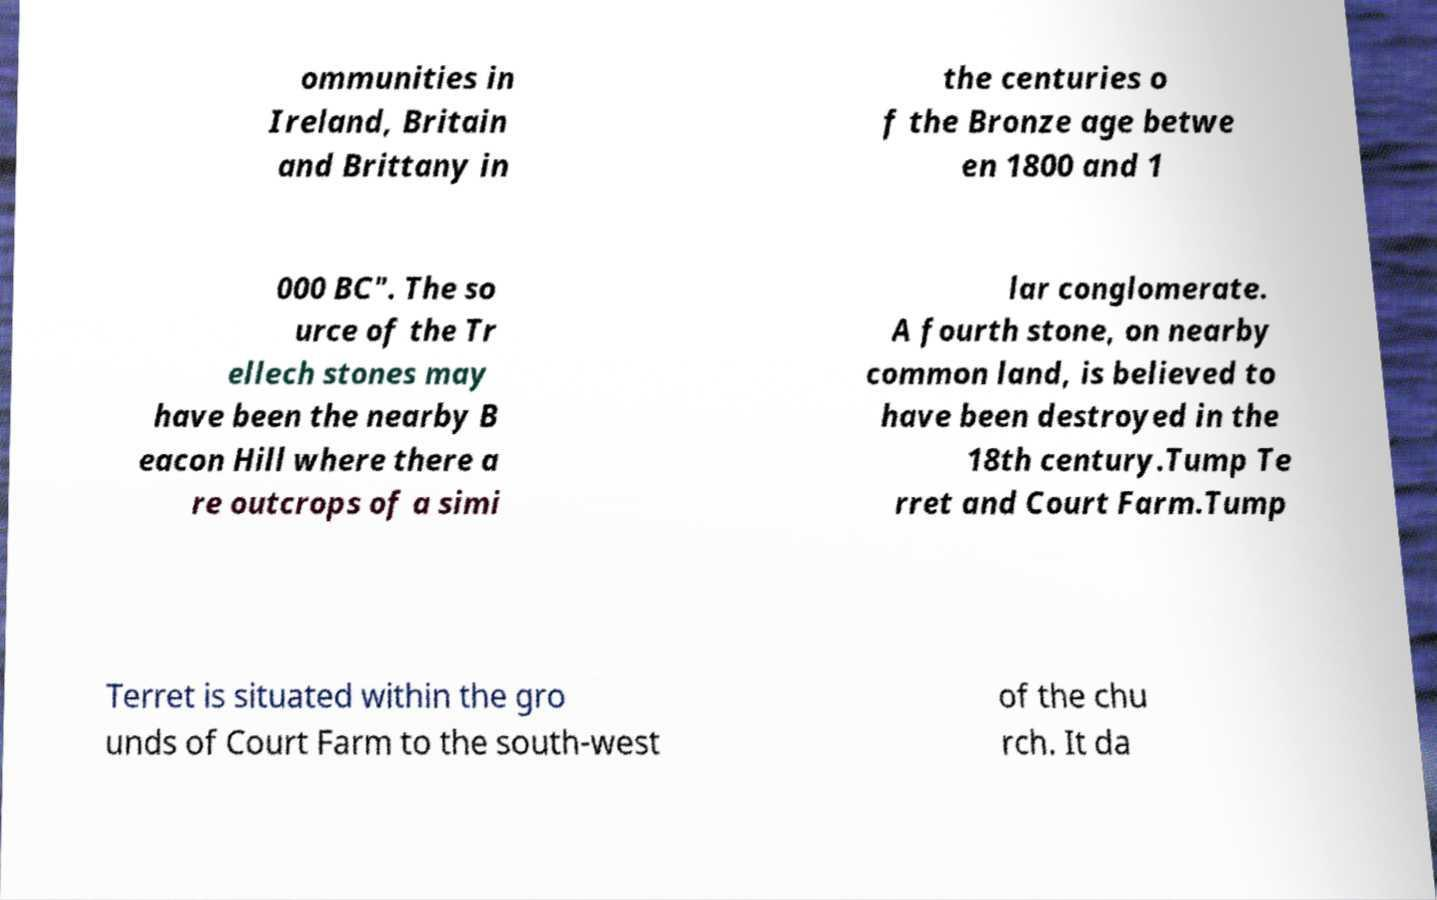I need the written content from this picture converted into text. Can you do that? ommunities in Ireland, Britain and Brittany in the centuries o f the Bronze age betwe en 1800 and 1 000 BC". The so urce of the Tr ellech stones may have been the nearby B eacon Hill where there a re outcrops of a simi lar conglomerate. A fourth stone, on nearby common land, is believed to have been destroyed in the 18th century.Tump Te rret and Court Farm.Tump Terret is situated within the gro unds of Court Farm to the south-west of the chu rch. It da 